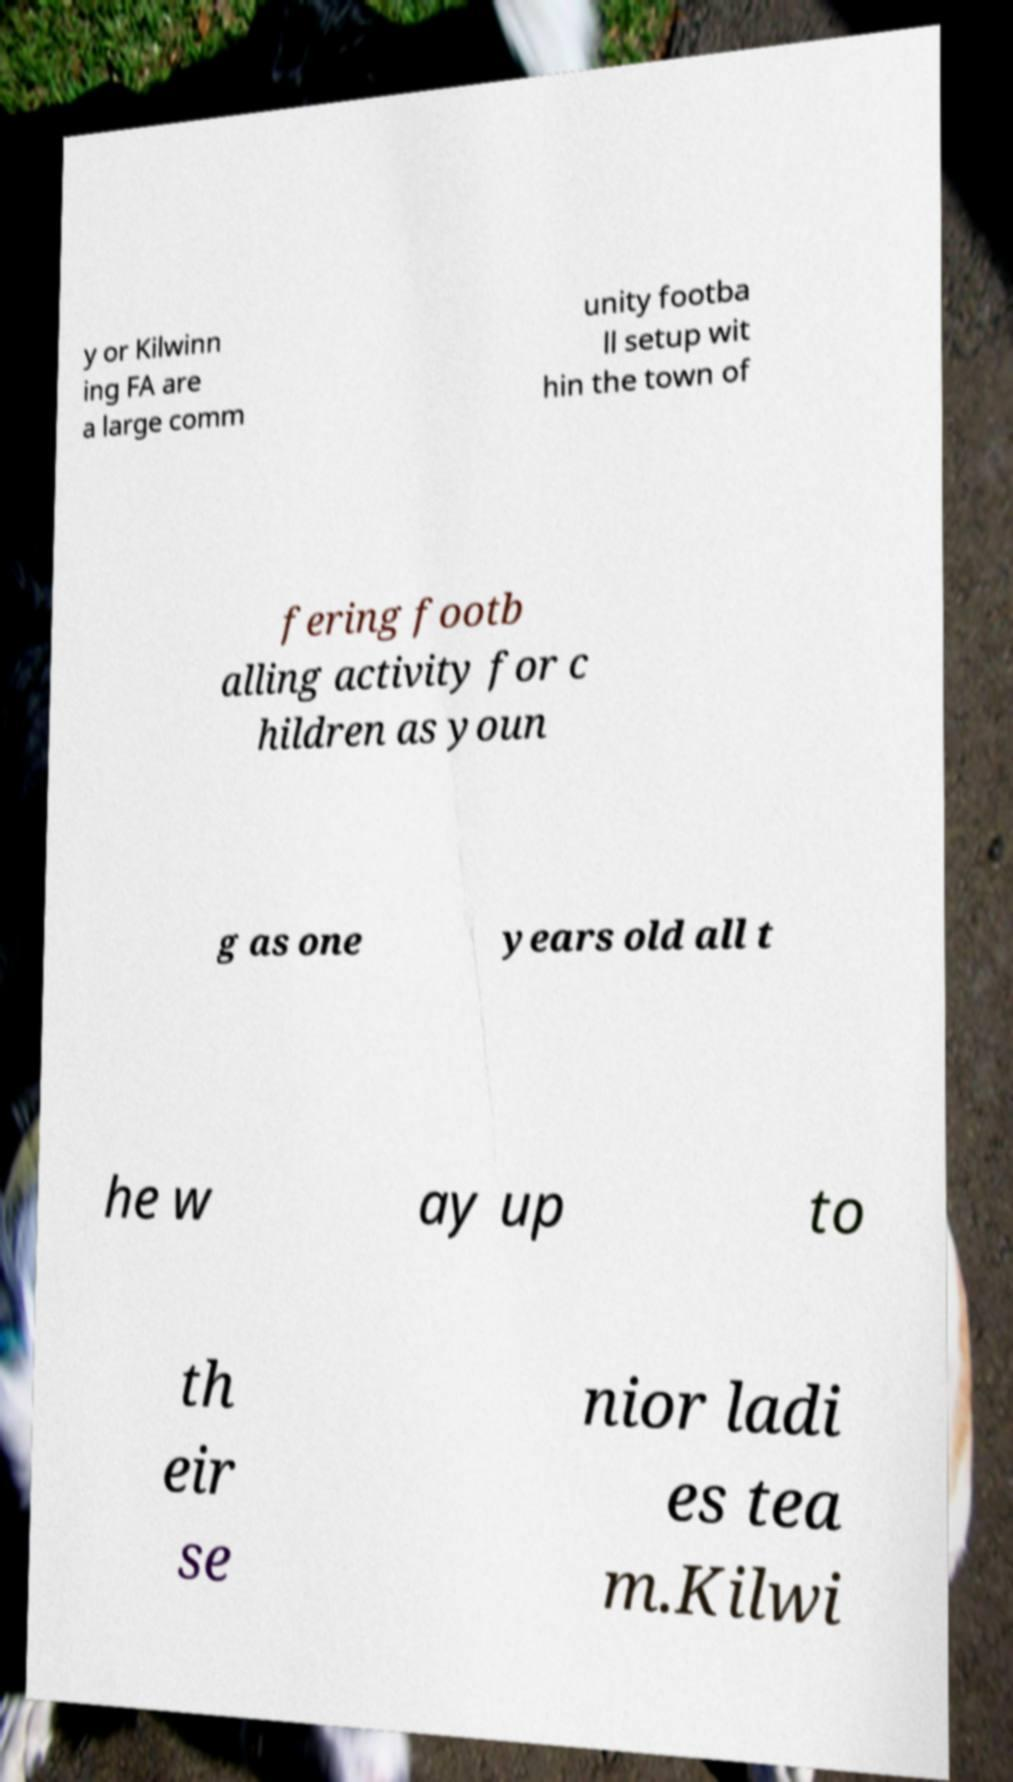Please read and relay the text visible in this image. What does it say? y or Kilwinn ing FA are a large comm unity footba ll setup wit hin the town of fering footb alling activity for c hildren as youn g as one years old all t he w ay up to th eir se nior ladi es tea m.Kilwi 